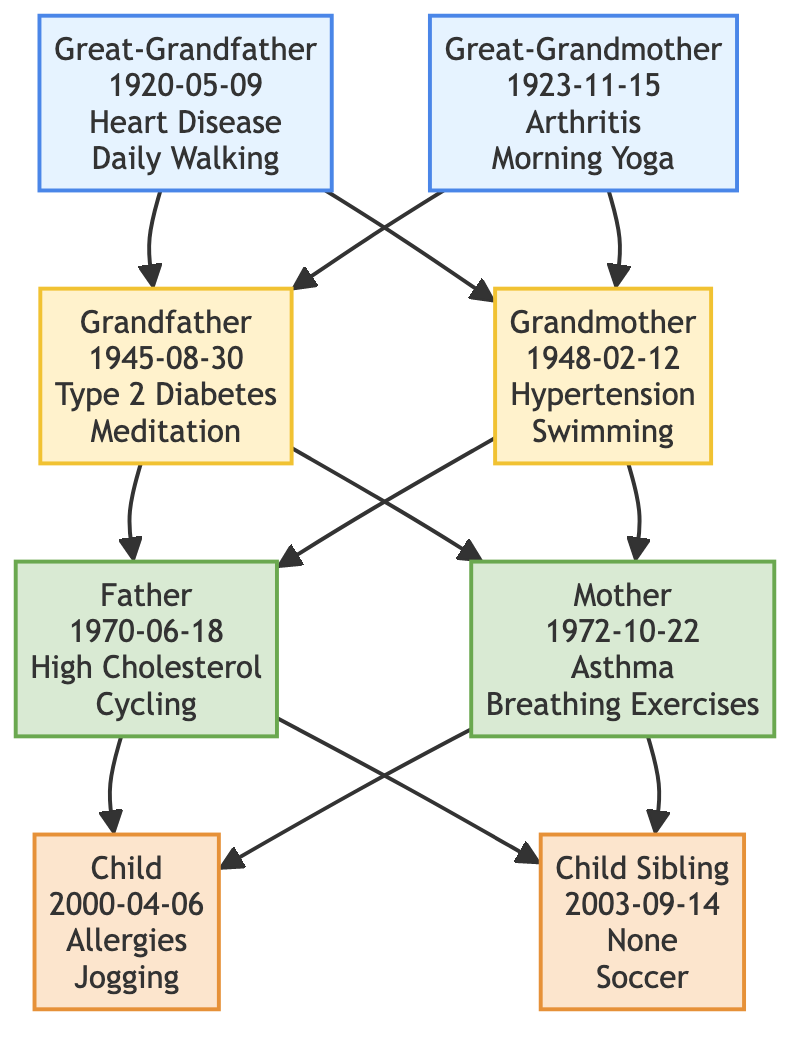What's the health condition of the Grandfather? The Grandfather node indicates that he has Type 2 Diabetes as his health condition. This information is explicitly mentioned in the details for the Grandfather.
Answer: Type 2 Diabetes How many nodes represent the fourth generation? From the diagram, there are two nodes at the fourth generation, which are the Child and Child Sibling. This can be counted directly from the lower-most nodes in the diagram.
Answer: 2 What wellness habit does the Grandmother practice? The Grandmother node states that her wellness habit is Swimming. This is part of the information provided for the Grandmother in the diagram.
Answer: Swimming Who is the child of the Father? The Father node is directly linked to the Child node, indicating that the Child is his offspring. This relationship is clearly shown in the connections of the diagram.
Answer: Child Which great-grandparent has Heart Disease? The Great-Grandfather node specifies that he has Heart Disease. This is a straightforward read from the information included for the Great-Grandfather.
Answer: Great-Grandfather How is the Mother related to the Grandfather? The Mother node connects to the Grandfather through a direct line, indicating that she is married to the Father, who is the son of the Grandfather. Thus, the Grandfather is her father-in-law.
Answer: Father-in-law What is the birth date of the Child sibling? The diagram lists the Child sibling's birth date as September 14, 2003. This can be directly answered by looking at the information provided for the Child Sibling node.
Answer: 2003-09-14 What is the wellness habit of the Great-Grandmother? According to the Great-Grandmother node, her wellness habit is Morning Yoga. This detail is specified in the Great-Grandmother's information.
Answer: Morning Yoga Which ancestor has the wellness habit of Daily Walking? The Great-Grandfather node mentions that his wellness habit is Daily Walking, making him the ancestor with this specific health practice. This is clearly indicated in his details.
Answer: Great-Grandfather 